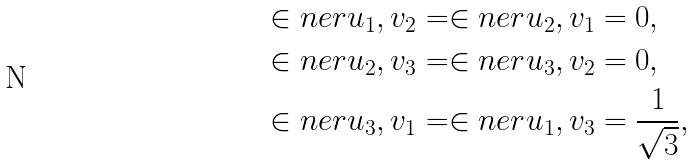Convert formula to latex. <formula><loc_0><loc_0><loc_500><loc_500>\in n e r { u _ { 1 } , v _ { 2 } } & = \in n e r { u _ { 2 } , v _ { 1 } } = 0 , \\ \in n e r { u _ { 2 } , v _ { 3 } } & = \in n e r { u _ { 3 } , v _ { 2 } } = 0 , \\ \in n e r { u _ { 3 } , v _ { 1 } } & = \in n e r { u _ { 1 } , v _ { 3 } } = \frac { 1 } { \sqrt { 3 } } ,</formula> 